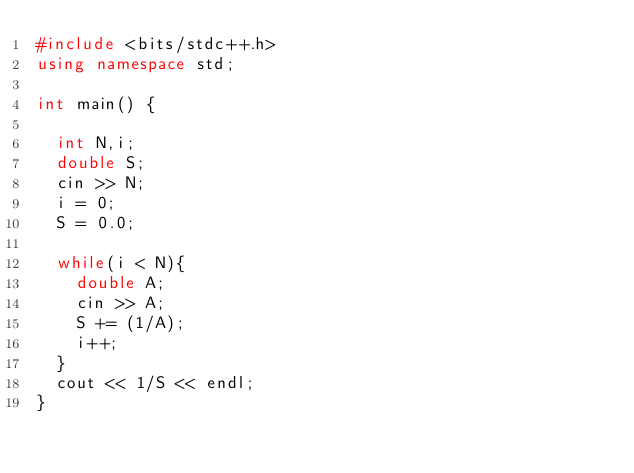Convert code to text. <code><loc_0><loc_0><loc_500><loc_500><_C++_>#include <bits/stdc++.h>
using namespace std;

int main() {
  
  int N,i;
  double S;
  cin >> N;
  i = 0;
  S = 0.0;
    
  while(i < N){
    double A;
    cin >> A;
    S += (1/A);
    i++;
  }
  cout << 1/S << endl;
}
    </code> 